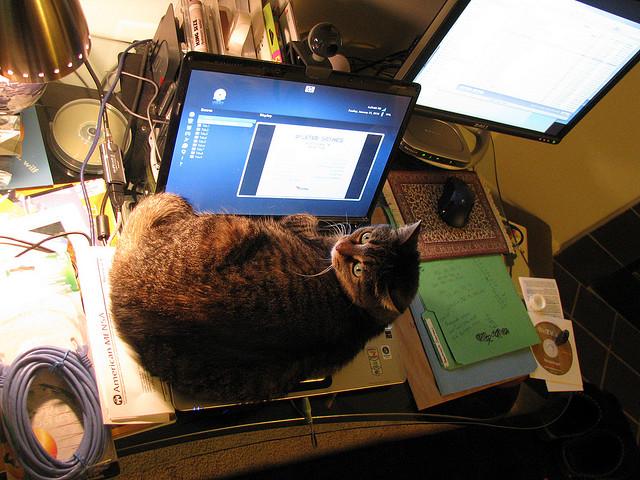How many computer monitors are shown?
Concise answer only. 2. What color is the animal?
Be succinct. Gray. What animal is shown?
Short answer required. Cat. 